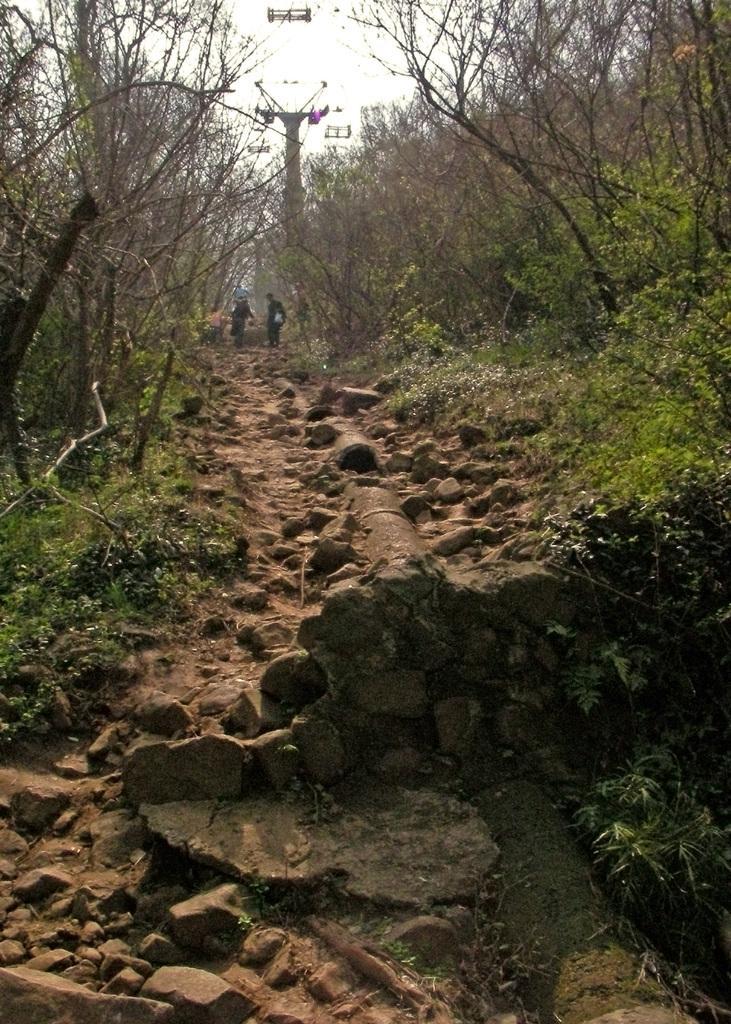In one or two sentences, can you explain what this image depicts? In this picture we see 2 people standing on a rocky walking path with trees and bushes on either side. 